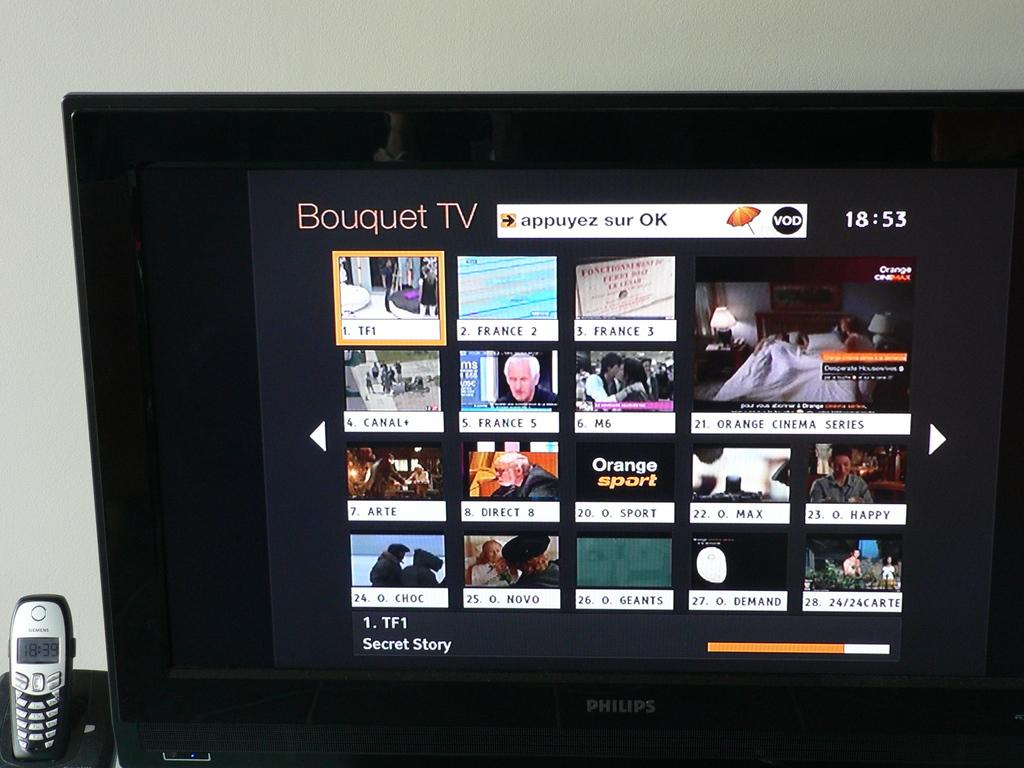Provide a one-sentence caption for the provided image. A phillips TV shows a channel called Bouquet TV with their programming. 